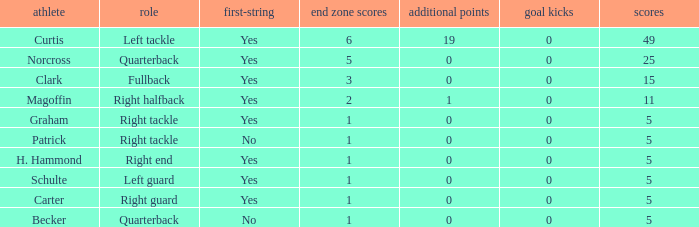Name the most touchdowns for norcross 5.0. 